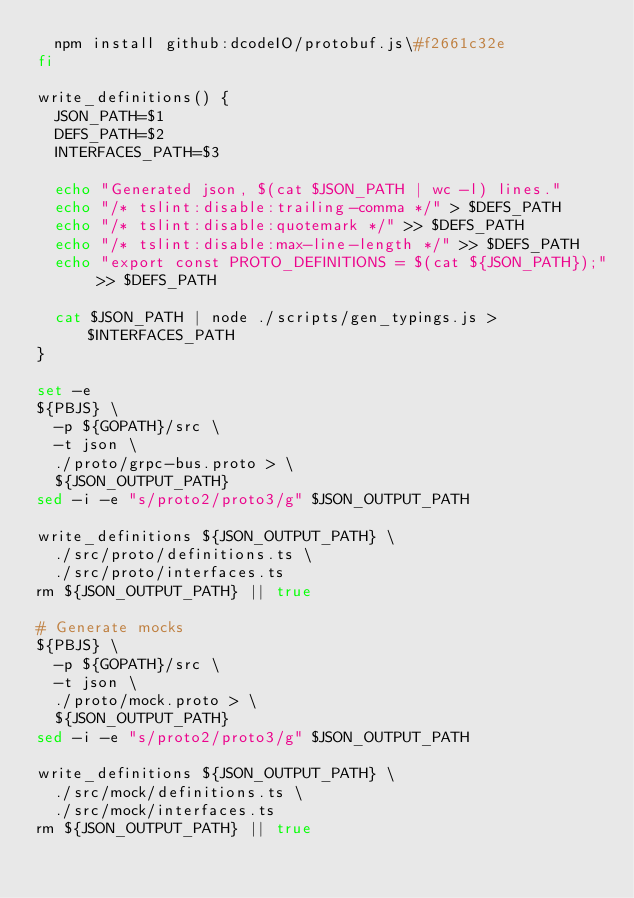Convert code to text. <code><loc_0><loc_0><loc_500><loc_500><_Bash_>  npm install github:dcodeIO/protobuf.js\#f2661c32e
fi

write_definitions() {
  JSON_PATH=$1
  DEFS_PATH=$2
  INTERFACES_PATH=$3

  echo "Generated json, $(cat $JSON_PATH | wc -l) lines."
  echo "/* tslint:disable:trailing-comma */" > $DEFS_PATH
  echo "/* tslint:disable:quotemark */" >> $DEFS_PATH
  echo "/* tslint:disable:max-line-length */" >> $DEFS_PATH
  echo "export const PROTO_DEFINITIONS = $(cat ${JSON_PATH});" >> $DEFS_PATH

  cat $JSON_PATH | node ./scripts/gen_typings.js > $INTERFACES_PATH
}

set -e
${PBJS} \
  -p ${GOPATH}/src \
  -t json \
  ./proto/grpc-bus.proto > \
  ${JSON_OUTPUT_PATH}
sed -i -e "s/proto2/proto3/g" $JSON_OUTPUT_PATH

write_definitions ${JSON_OUTPUT_PATH} \
  ./src/proto/definitions.ts \
  ./src/proto/interfaces.ts
rm ${JSON_OUTPUT_PATH} || true

# Generate mocks
${PBJS} \
  -p ${GOPATH}/src \
  -t json \
  ./proto/mock.proto > \
  ${JSON_OUTPUT_PATH}
sed -i -e "s/proto2/proto3/g" $JSON_OUTPUT_PATH

write_definitions ${JSON_OUTPUT_PATH} \
  ./src/mock/definitions.ts \
  ./src/mock/interfaces.ts
rm ${JSON_OUTPUT_PATH} || true
</code> 